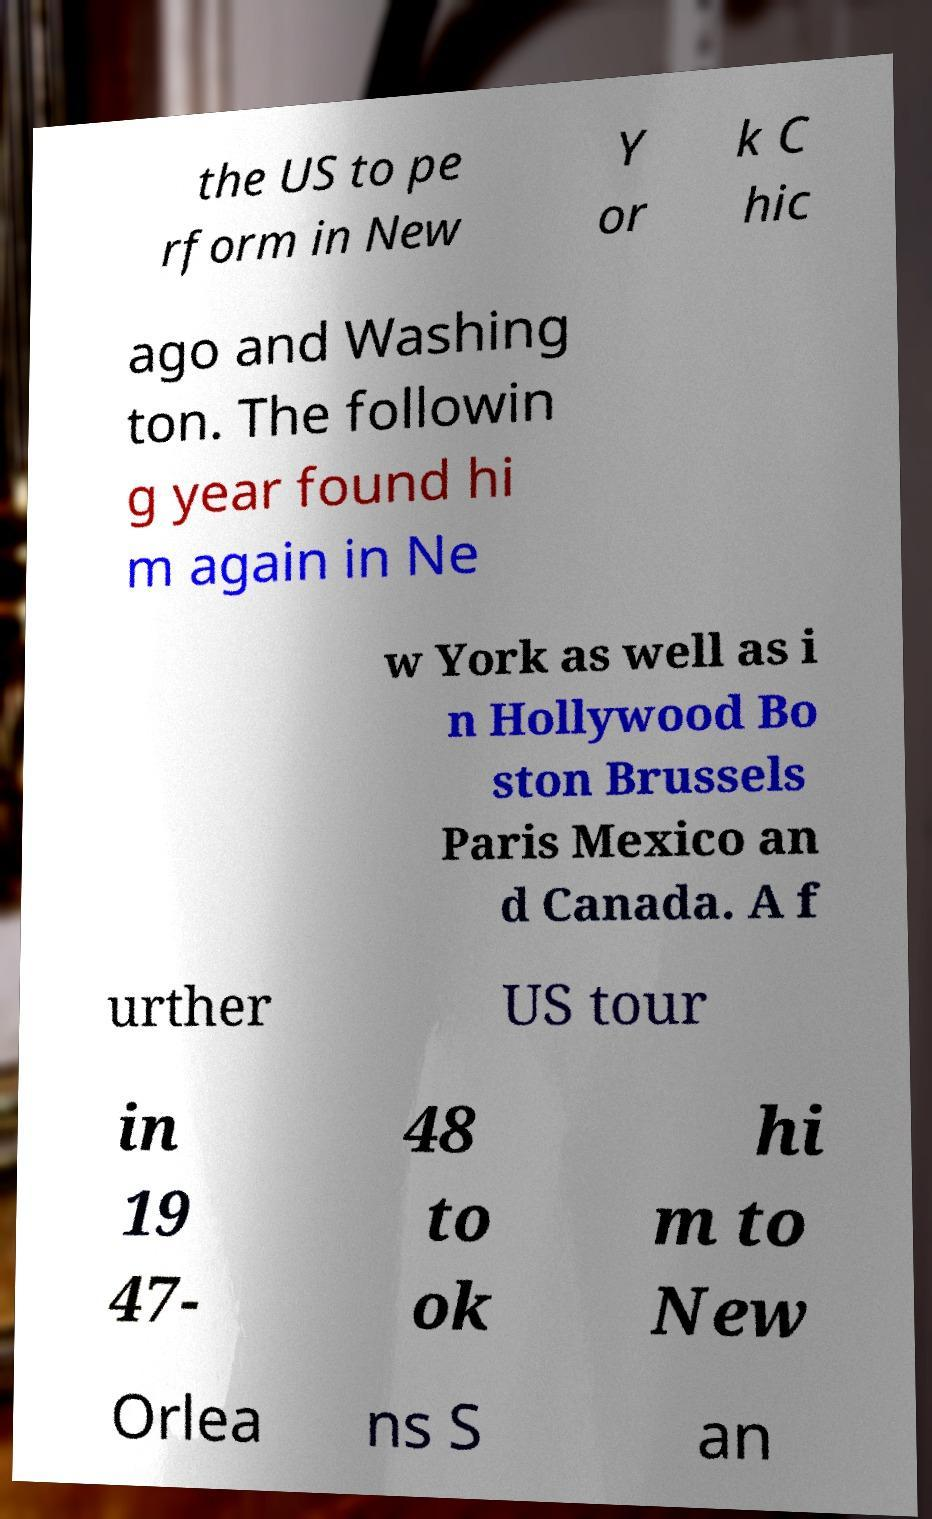I need the written content from this picture converted into text. Can you do that? the US to pe rform in New Y or k C hic ago and Washing ton. The followin g year found hi m again in Ne w York as well as i n Hollywood Bo ston Brussels Paris Mexico an d Canada. A f urther US tour in 19 47- 48 to ok hi m to New Orlea ns S an 